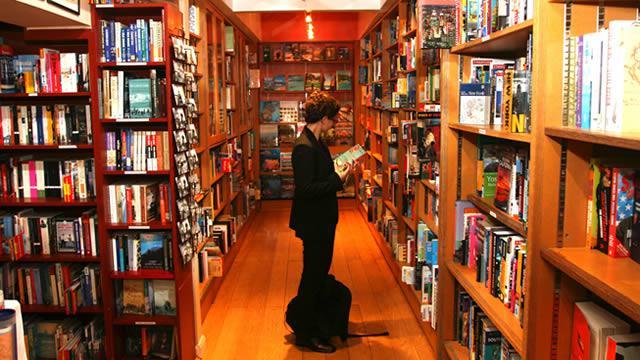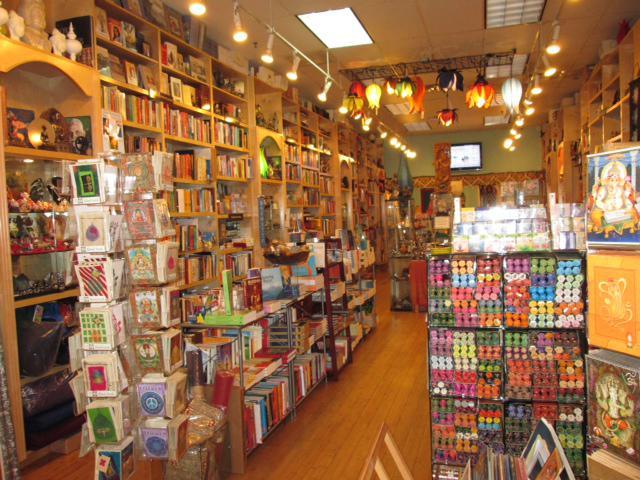The first image is the image on the left, the second image is the image on the right. Considering the images on both sides, is "A woman with dark hair and wearing a black jacket is in a bookstore in one image." valid? Answer yes or no. Yes. The first image is the image on the left, the second image is the image on the right. Evaluate the accuracy of this statement regarding the images: "Left image contains a person wearing a black blazer.". Is it true? Answer yes or no. Yes. The first image is the image on the left, the second image is the image on the right. For the images shown, is this caption "There is one woman wearing black in the lefthand image." true? Answer yes or no. Yes. The first image is the image on the left, the second image is the image on the right. Analyze the images presented: Is the assertion "there is exactly one person in the image on the left" valid? Answer yes or no. Yes. 